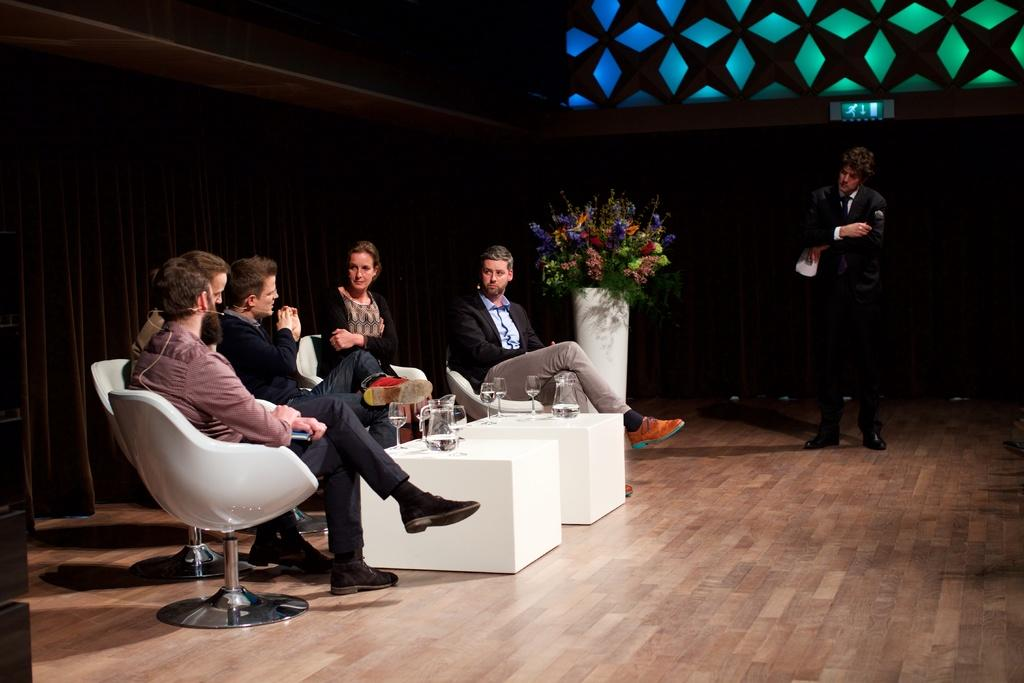What is happening in the image? There is a group of people in the image, and they are sitting. What are the people doing while sitting? The people are speaking with each other. Where is the faucet located in the image? There is no faucet present in the image. How many oranges are on the table in the image? There are no oranges present in the image. 